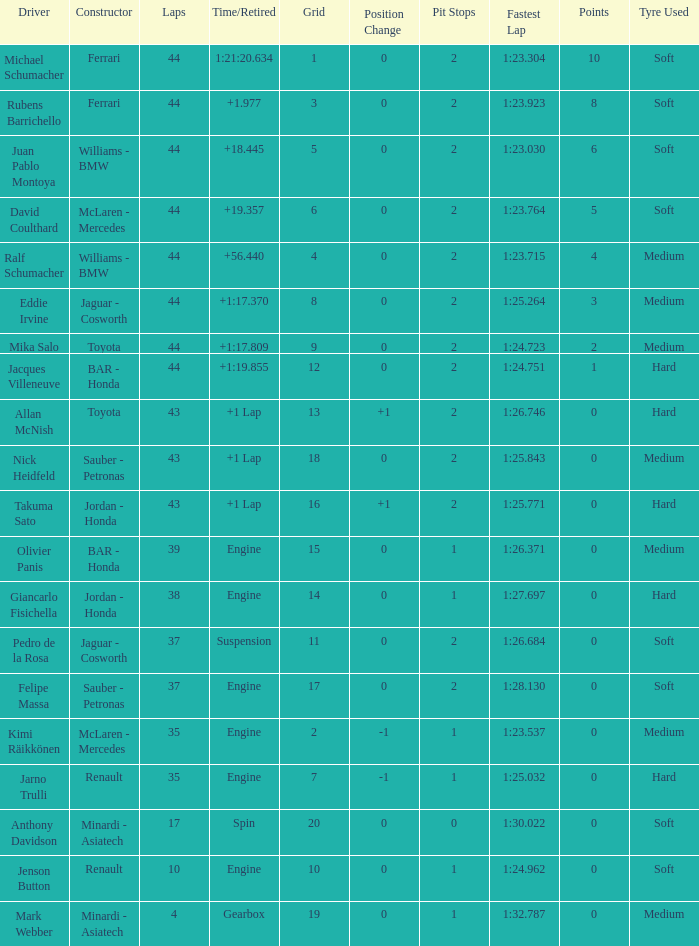What was the time of the driver on grid 3? 1.977. 